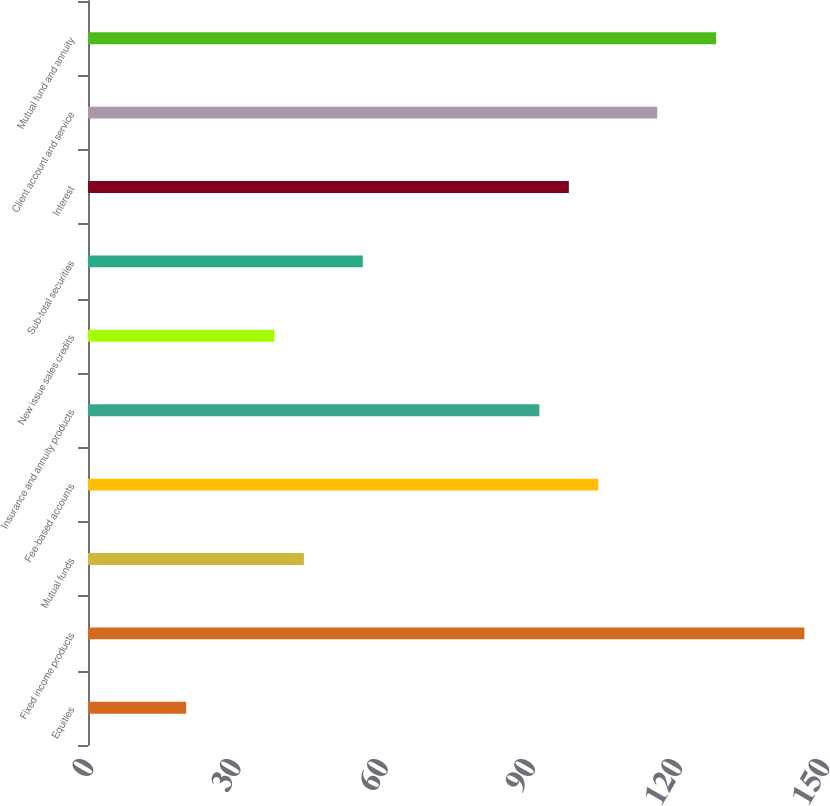<chart> <loc_0><loc_0><loc_500><loc_500><bar_chart><fcel>Equities<fcel>Fixed income products<fcel>Mutual funds<fcel>Fee-based accounts<fcel>Insurance and annuity products<fcel>New issue sales credits<fcel>Sub-total securities<fcel>Interest<fcel>Client account and service<fcel>Mutual fund and annuity<nl><fcel>20<fcel>146<fcel>44<fcel>104<fcel>92<fcel>38<fcel>56<fcel>98<fcel>116<fcel>128<nl></chart> 